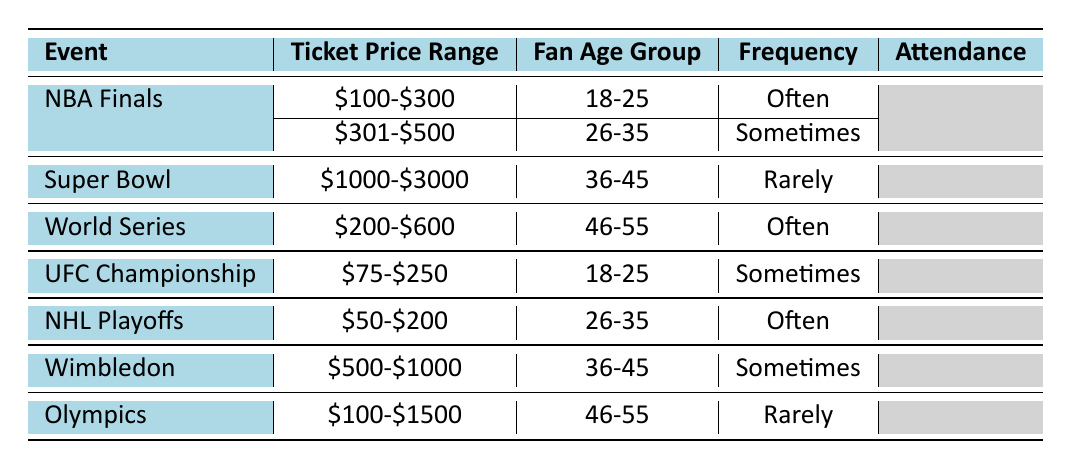What is the frequency of attendance for the NBA Finals for the 18-25 age group? The table indicates that the NBA Finals has an entry for the 18-25 age group, and it states that the frequency of attendance is "Often".
Answer: Often How many different ticket price ranges are represented in the table? By examining the ticket price range column, we can see the ranges are \$100-\$300, \$301-\$500, \$1000-\$3000, \$200-\$600, \$75-\$250, \$50-\$200, and \$500-\$1000. This gives us a total of 6 distinct price ranges.
Answer: 6 Is there any event that attracts fans aged 36-45 who attend rarely? The table shows the Super Bowl and the Olympics for fans aged 36-45, both indicating a frequency of attendance of "Rarely". Thus, the answer is yes.
Answer: Yes What is the most common frequency of attendance for fans aged 18-25? There are two entries for the 18-25 age group: one for the NBA Finals which is "Often" and one for the UFC Championship which is "Sometimes". Counting these gives us one instance of "Often" and one of "Sometimes", therefore the most common frequency is "Often".
Answer: Often Which age group has the highest frequency of attending events? Reviewing the table reveals that the 18-25 and 26-35 age groups have “Often” attendance for the NBA Finals and NHL Playoffs respectively, creating a tie for the highest frequency. However, since both categories have "Often", they equally represent the highest frequency of attendance.
Answer: 18-25 and 26-35 What is the total number of events listed for fans aged 46-55? In the table, the events listed for the age group 46-55 are the World Series, Olympics, and the Super Bowl. Thus, there are 2 entries for events in this age group.
Answer: 2 Do fans aged 26-35 attend the World Series? The table does not have any entries for fans aged 26-35 attending the World Series, indicating that the answer is no.
Answer: No Which sport has a ticket price range of 100-300 and attracts fans who attend often? The NBA Finals is listed with the ticket price range of 100-300, and the corresponding frequency of attendance is "Often".
Answer: NBA Finals How many distinct sports events are associated with fans who attend sometimes? By checking the table, we find three events associated with “Sometimes” attendance, which are the NBA Finals, Wimbledon, and UFC Championship.
Answer: 3 